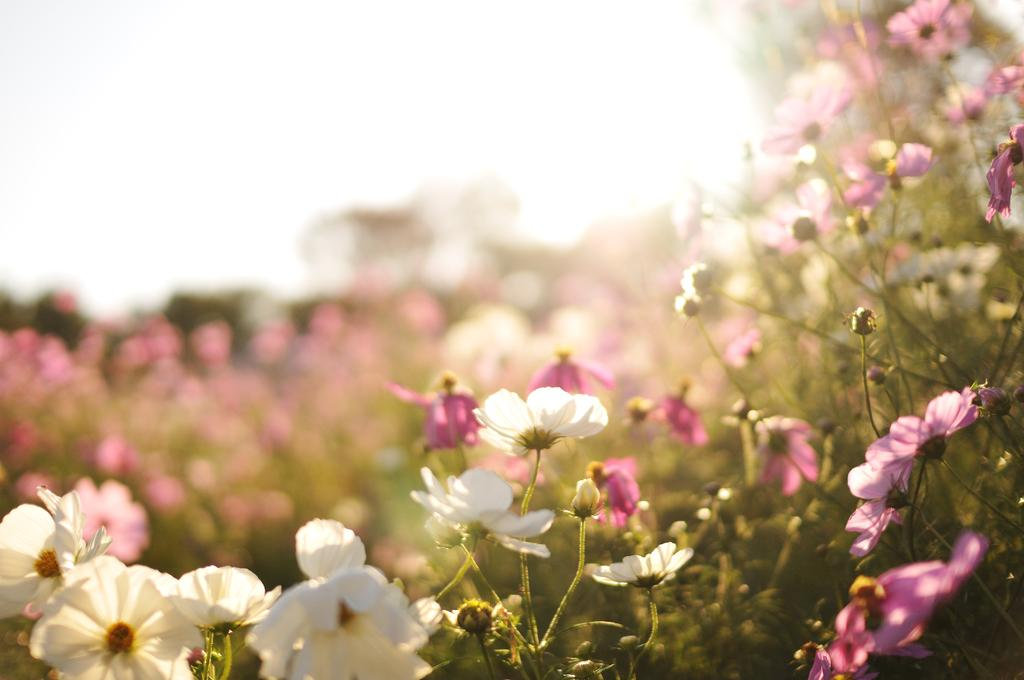What type of plants are in the image? There are plants with many flowers in the image. Can you describe the flowers on the plants? The flowers are not specifically described, but they are present on the plants. What else can be seen in the background of the image? There are additional flowers visible in the background, although they may not be clearly visible. What type of horn is being played by the writer in the image? There is no writer or horn present in the image; it features plants with many flowers and additional flowers in the background. 